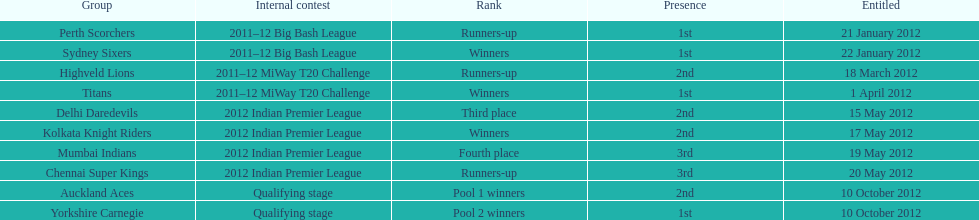Which teams were the last to qualify? Auckland Aces, Yorkshire Carnegie. 